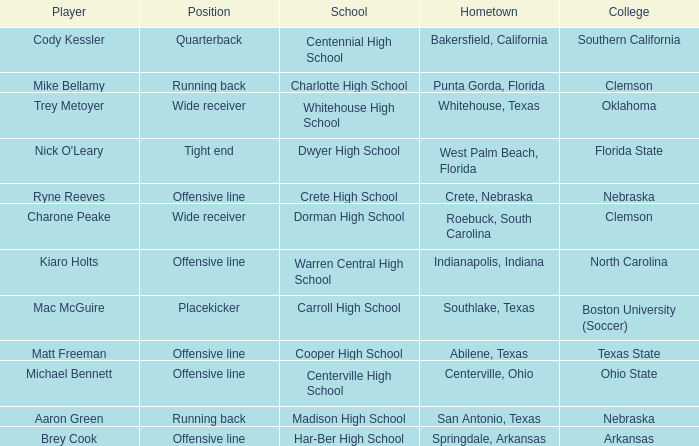What was the position of the player that went to warren central high school? Offensive line. 